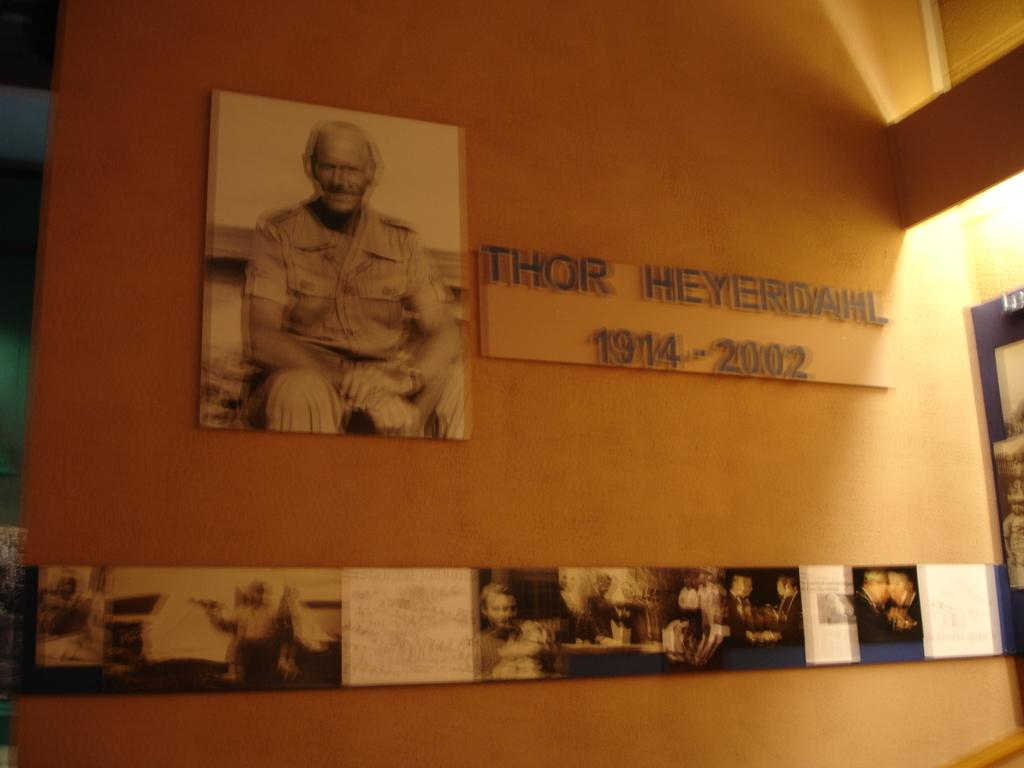What is on the wall in the foreground of the image? There are posters on the wall in the foreground of the image. What else can be seen on the wall besides the posters? There is a text board on the wall. Can you describe the lighting in the image? A light is visible on the right side of the image. Where is the hen located in the image? There is no hen present in the image. What type of fiction is being displayed on the posters in the image? The posters in the image do not depict any fiction; they are not described in the provided facts. 